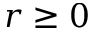Convert formula to latex. <formula><loc_0><loc_0><loc_500><loc_500>r \geq 0</formula> 